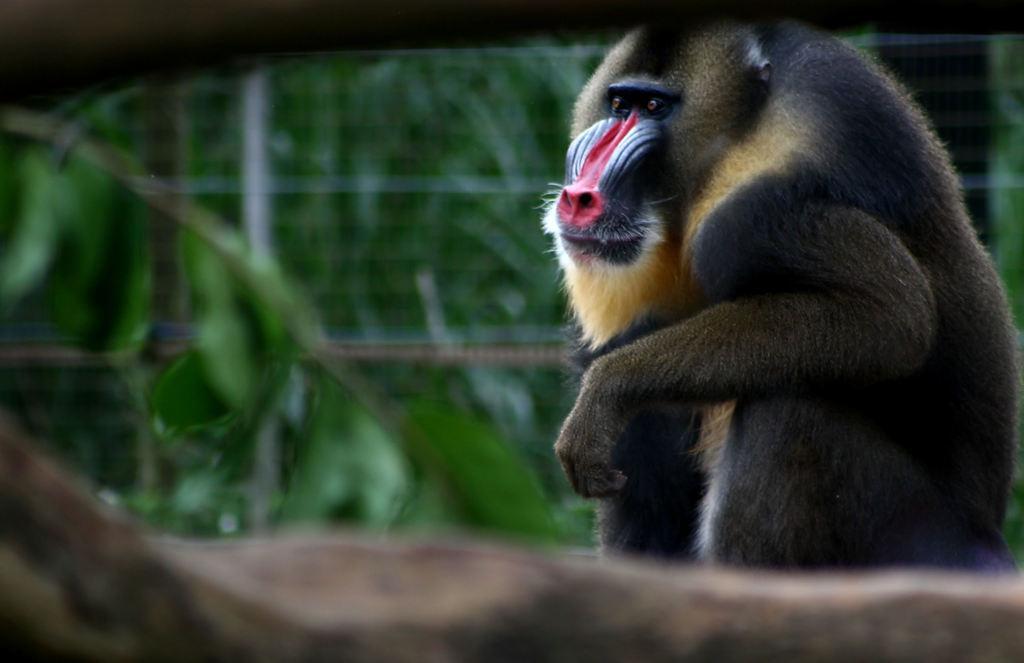Describe this image in one or two sentences. In this image I can see a baboon. The background of the image is blurred. 